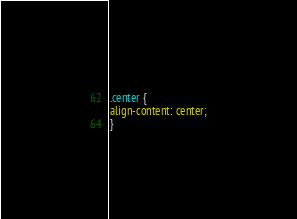Convert code to text. <code><loc_0><loc_0><loc_500><loc_500><_CSS_>.center {
align-content: center;
}
</code> 